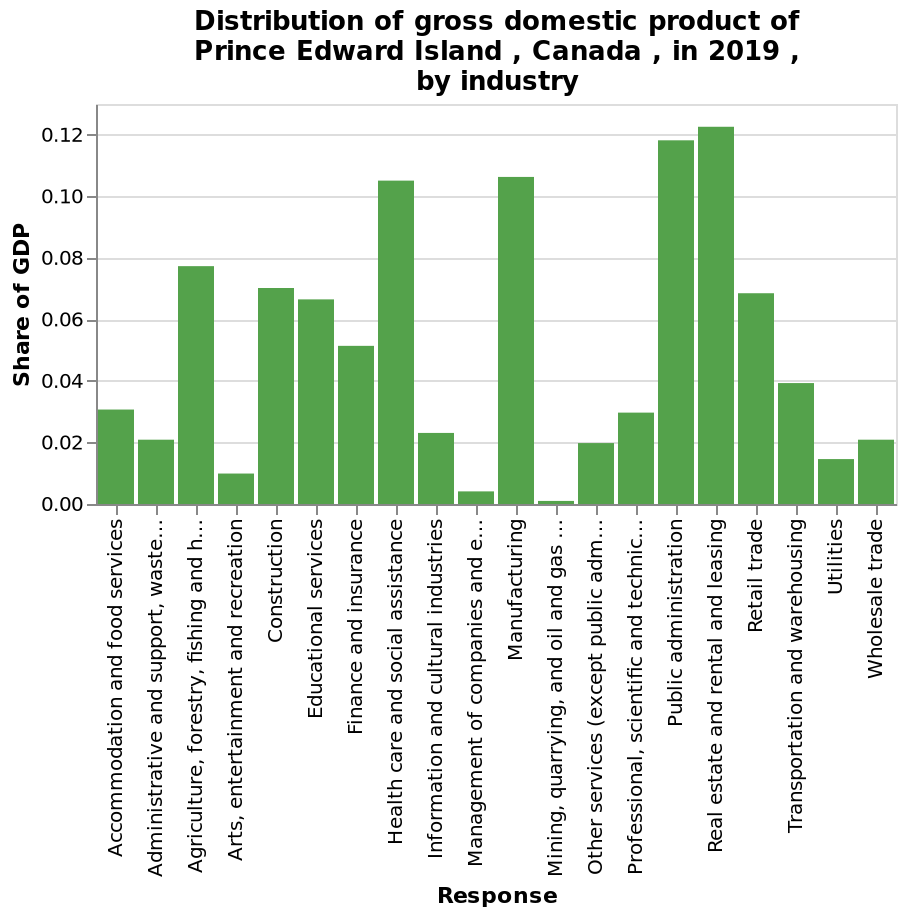<image>
Which industry is represented by the left end of the x-axis? The left end of the x-axis represents the Accommodation and food services industry. Offer a thorough analysis of the image. Gross domestic product of Prince Edward Island is varied. 